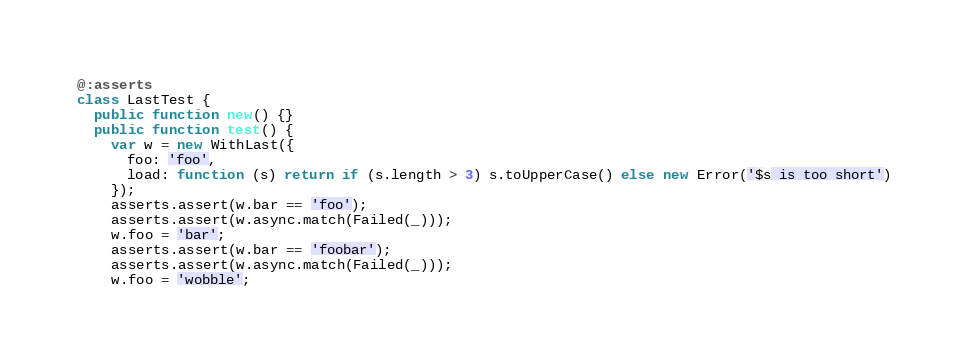Convert code to text. <code><loc_0><loc_0><loc_500><loc_500><_Haxe_>@:asserts
class LastTest {
  public function new() {}
  public function test() {
    var w = new WithLast({
      foo: 'foo',
      load: function (s) return if (s.length > 3) s.toUpperCase() else new Error('$s is too short')
    });
    asserts.assert(w.bar == 'foo');
    asserts.assert(w.async.match(Failed(_)));
    w.foo = 'bar';
    asserts.assert(w.bar == 'foobar');
    asserts.assert(w.async.match(Failed(_)));
    w.foo = 'wobble';</code> 